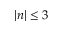Convert formula to latex. <formula><loc_0><loc_0><loc_500><loc_500>| n | \leq 3</formula> 